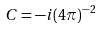Convert formula to latex. <formula><loc_0><loc_0><loc_500><loc_500>C = - i ( 4 \pi ) ^ { - 2 }</formula> 